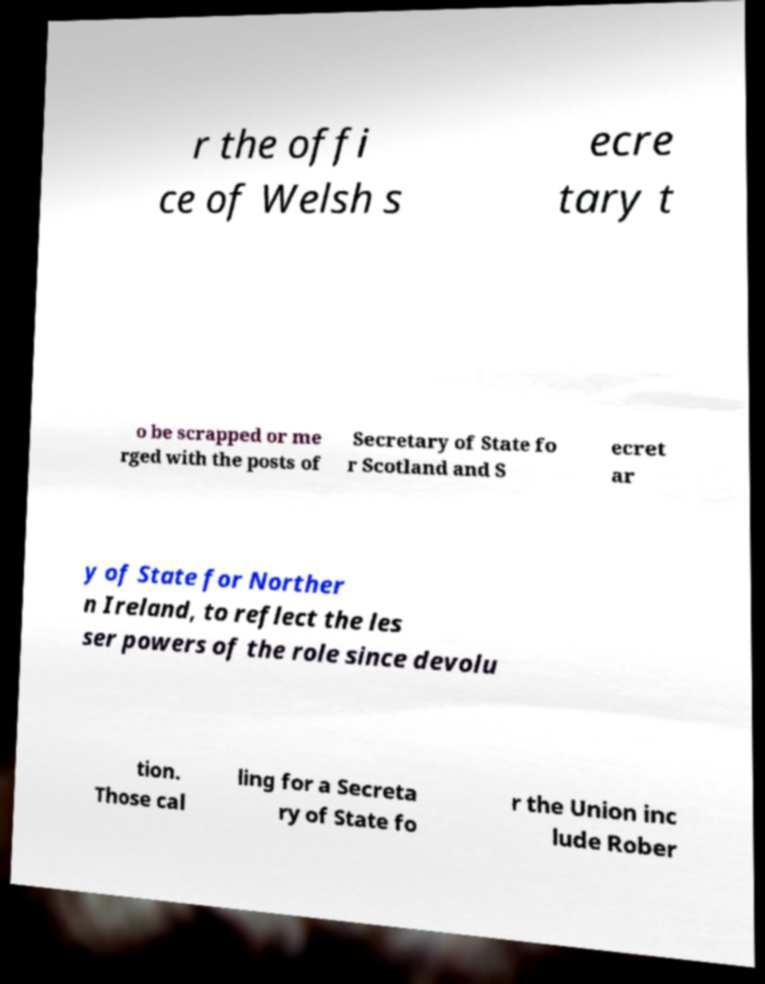Can you accurately transcribe the text from the provided image for me? r the offi ce of Welsh s ecre tary t o be scrapped or me rged with the posts of Secretary of State fo r Scotland and S ecret ar y of State for Norther n Ireland, to reflect the les ser powers of the role since devolu tion. Those cal ling for a Secreta ry of State fo r the Union inc lude Rober 